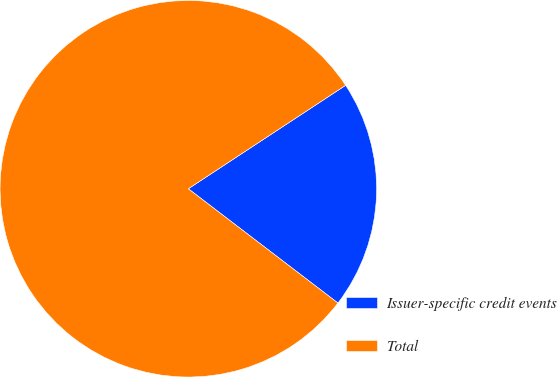Convert chart to OTSL. <chart><loc_0><loc_0><loc_500><loc_500><pie_chart><fcel>Issuer-specific credit events<fcel>Total<nl><fcel>19.64%<fcel>80.36%<nl></chart> 